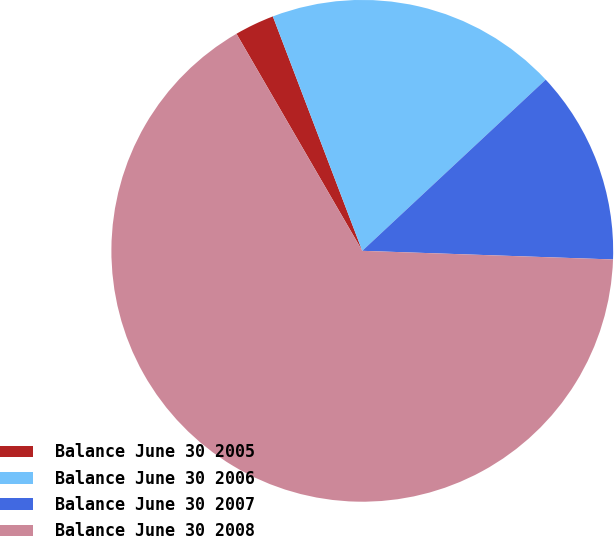<chart> <loc_0><loc_0><loc_500><loc_500><pie_chart><fcel>Balance June 30 2005<fcel>Balance June 30 2006<fcel>Balance June 30 2007<fcel>Balance June 30 2008<nl><fcel>2.56%<fcel>18.85%<fcel>12.5%<fcel>66.09%<nl></chart> 